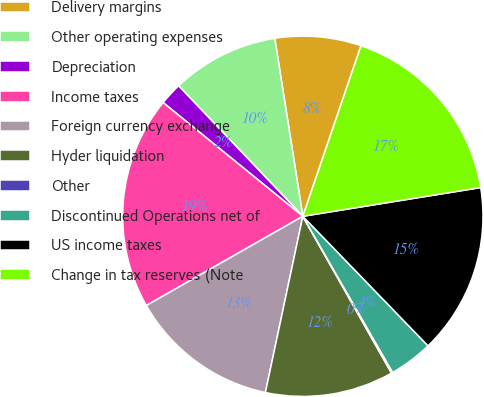Convert chart to OTSL. <chart><loc_0><loc_0><loc_500><loc_500><pie_chart><fcel>Delivery margins<fcel>Other operating expenses<fcel>Depreciation<fcel>Income taxes<fcel>Foreign currency exchange<fcel>Hyder liquidation<fcel>Other<fcel>Discontinued Operations net of<fcel>US income taxes<fcel>Change in tax reserves (Note<nl><fcel>7.72%<fcel>9.62%<fcel>2.02%<fcel>19.12%<fcel>13.42%<fcel>11.52%<fcel>0.12%<fcel>3.92%<fcel>15.32%<fcel>17.22%<nl></chart> 